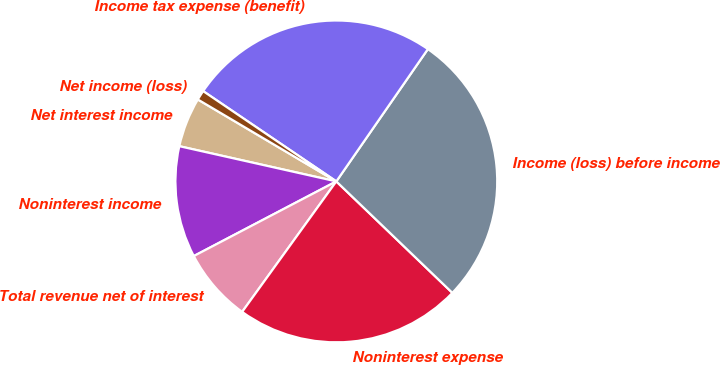Convert chart. <chart><loc_0><loc_0><loc_500><loc_500><pie_chart><fcel>Net interest income<fcel>Noninterest income<fcel>Total revenue net of interest<fcel>Noninterest expense<fcel>Income (loss) before income<fcel>Income tax expense (benefit)<fcel>Net income (loss)<nl><fcel>4.99%<fcel>11.19%<fcel>7.37%<fcel>22.77%<fcel>27.54%<fcel>25.15%<fcel>0.98%<nl></chart> 